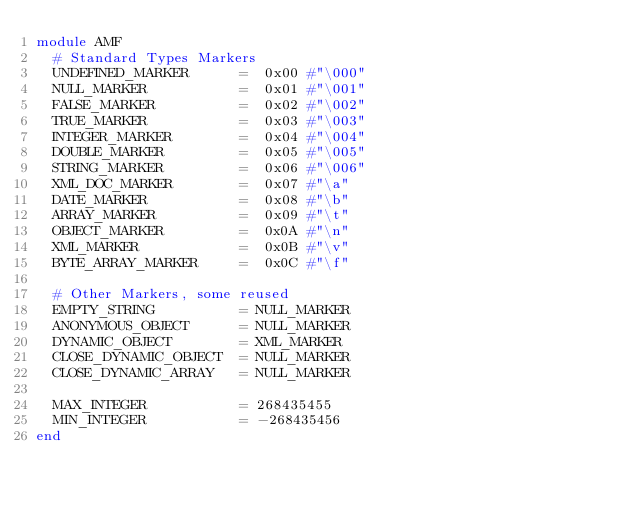Convert code to text. <code><loc_0><loc_0><loc_500><loc_500><_Ruby_>module AMF
  # Standard Types Markers
  UNDEFINED_MARKER      =  0x00 #"\000"
  NULL_MARKER           =  0x01 #"\001"
  FALSE_MARKER          =  0x02 #"\002"
  TRUE_MARKER           =  0x03 #"\003" 
  INTEGER_MARKER        =  0x04 #"\004" 
  DOUBLE_MARKER         =  0x05 #"\005" 
  STRING_MARKER         =  0x06 #"\006"
  XML_DOC_MARKER        =  0x07 #"\a" 
  DATE_MARKER           =  0x08 #"\b" 
  ARRAY_MARKER          =  0x09 #"\t" 
  OBJECT_MARKER         =  0x0A #"\n" 
  XML_MARKER            =  0x0B #"\v" 
  BYTE_ARRAY_MARKER     =  0x0C #"\f" 
  
  # Other Markers, some reused
  EMPTY_STRING          = NULL_MARKER
  ANONYMOUS_OBJECT      = NULL_MARKER
  DYNAMIC_OBJECT        = XML_MARKER
  CLOSE_DYNAMIC_OBJECT  = NULL_MARKER
  CLOSE_DYNAMIC_ARRAY   = NULL_MARKER

  MAX_INTEGER           = 268435455
  MIN_INTEGER           = -268435456
end</code> 